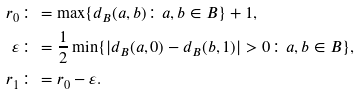<formula> <loc_0><loc_0><loc_500><loc_500>r _ { 0 } & \colon = \max \{ d _ { B } ( a , b ) \colon a , b \in B \} + 1 , \\ \varepsilon & \colon = \frac { 1 } { 2 } \min \{ | d _ { B } ( a , 0 ) - d _ { B } ( b , 1 ) | > 0 \colon a , b \in B \} , \\ r _ { 1 } & \colon = r _ { 0 } - \varepsilon .</formula> 